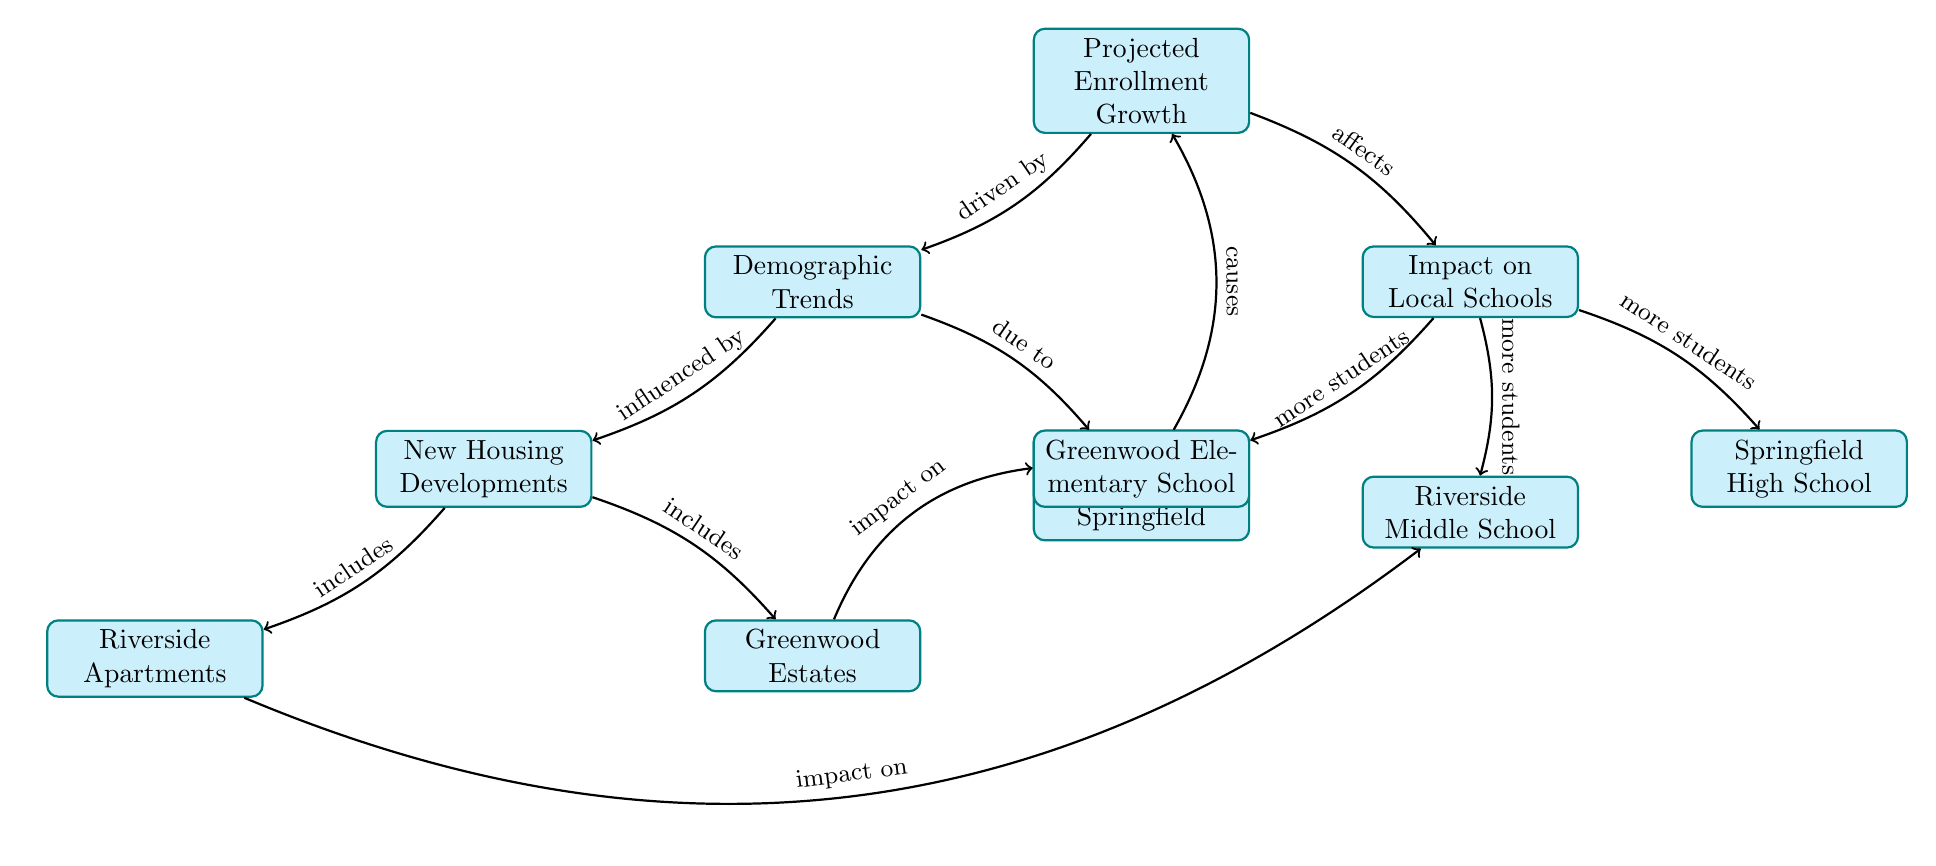What is the main topic represented in the diagram? The main topic represented in the diagram is "Projected Enrollment Growth". It is the topmost node, indicating the central focus of the entire diagram.
Answer: Projected Enrollment Growth How many schools are affected by the projected enrollment growth? The diagram lists three schools: Springfield High School, Riverside Middle School, and Greenwood Elementary School. Counting these gives three affected schools.
Answer: 3 What influences the "Projected Enrollment Growth"? The "Projected Enrollment Growth" is influenced by "Demographic Trends" as indicated by the directed edge connecting these two nodes.
Answer: Demographic Trends Which node includes the Riverside Apartments? The "Riverside Apartments" is included under the node "New Housing Developments," as indicated by the directed edge leading from "New Housing Developments" to "Riverside Apartments."
Answer: New Housing Developments What is the connection between Population Increase in Springfield and the Projected Enrollment Growth? The connection is stated that "Population Increase in Springfield" causes "Projected Enrollment Growth" as indicated by the directed edge in the diagram.
Answer: causes How do New Housing Developments impact the schools? The "New Housing Developments" are indicated to have an impact on "Riverside Middle School" and "Greenwood Elementary School," as shown by the directed edges from the "New Housing Developments" node to these respective school nodes.
Answer: impact on Riverside Middle School and Greenwood Elementary School What is the relationship between the "Demographic Trends" and "New Housing Developments"? "Demographic Trends" influences the "New Housing Developments," which is captured in the directed edge connecting these two nodes.
Answer: influences Which housing development is mentioned to impact Riverside Middle School? The "Riverside Apartments" is specifically mentioned to have an impact on "Riverside Middle School," as indicated by the directed edge from "Riverside Apartments" to "Riverside Middle School."
Answer: Riverside Apartments 